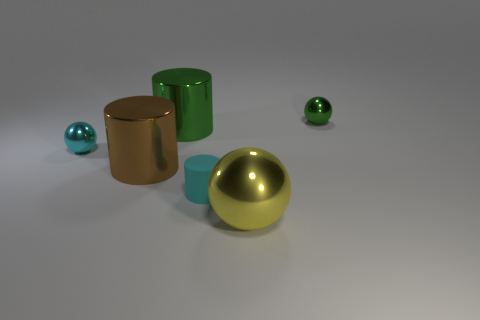Add 4 cyan rubber cylinders. How many objects exist? 10 Subtract 0 brown balls. How many objects are left? 6 Subtract all small purple shiny cylinders. Subtract all small green balls. How many objects are left? 5 Add 3 cylinders. How many cylinders are left? 6 Add 4 brown metal things. How many brown metal things exist? 5 